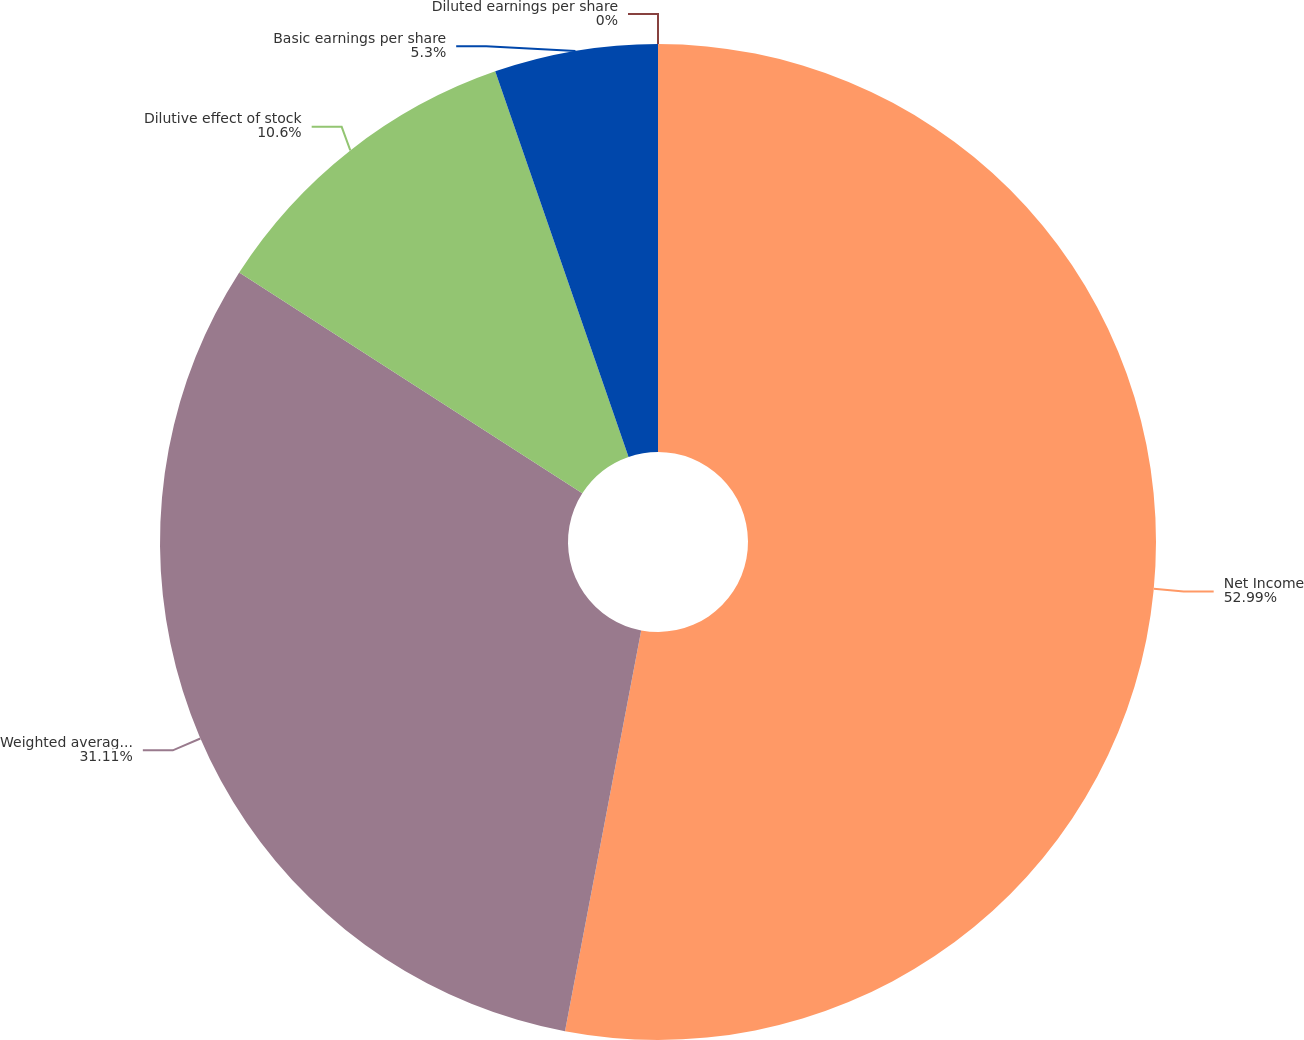Convert chart. <chart><loc_0><loc_0><loc_500><loc_500><pie_chart><fcel>Net Income<fcel>Weighted average shares<fcel>Dilutive effect of stock<fcel>Basic earnings per share<fcel>Diluted earnings per share<nl><fcel>52.99%<fcel>31.11%<fcel>10.6%<fcel>5.3%<fcel>0.0%<nl></chart> 